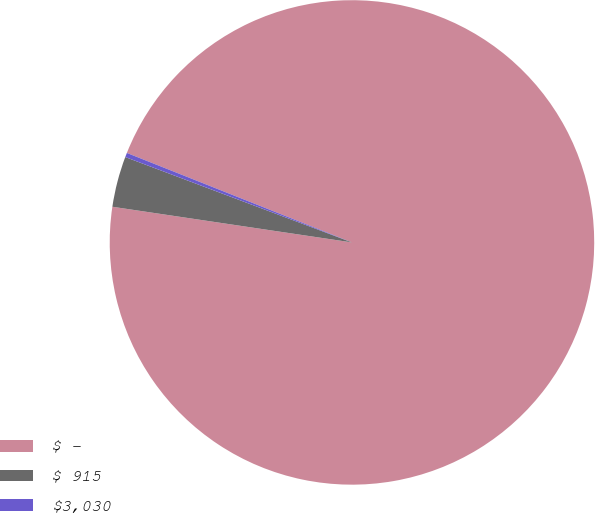Convert chart. <chart><loc_0><loc_0><loc_500><loc_500><pie_chart><fcel>$ -<fcel>$ 915<fcel>$3,030<nl><fcel>96.33%<fcel>3.38%<fcel>0.29%<nl></chart> 